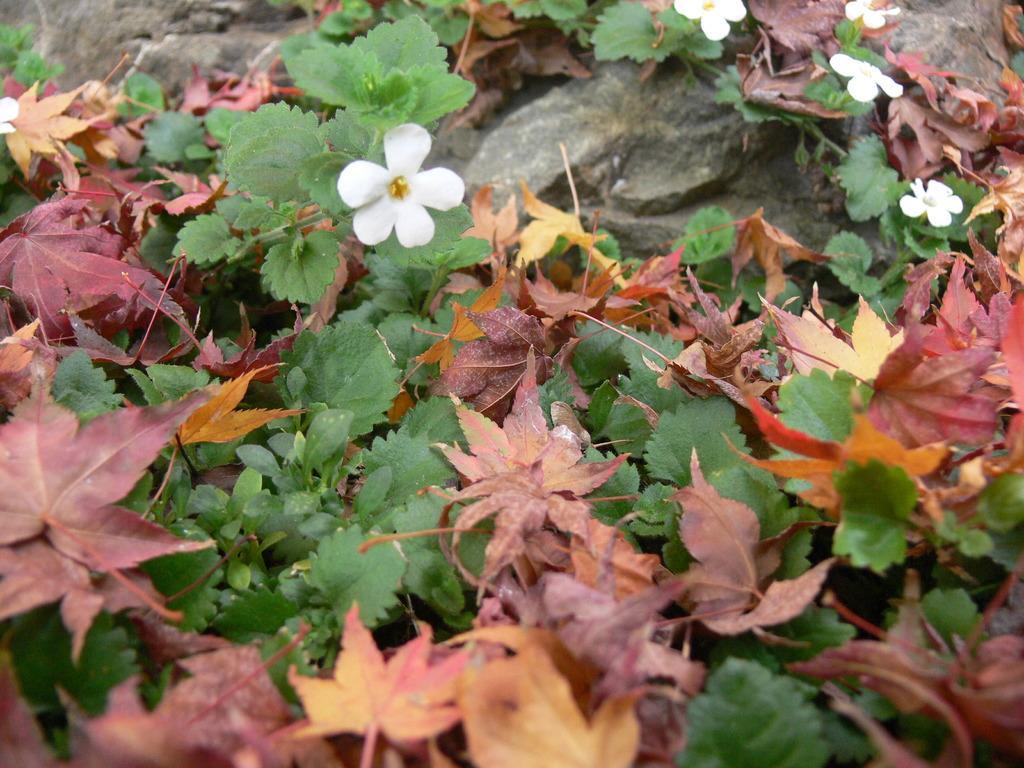Can you describe this image briefly? In this picture I can see there are few dry leaves, plants with white color flowers and there is a rock. 